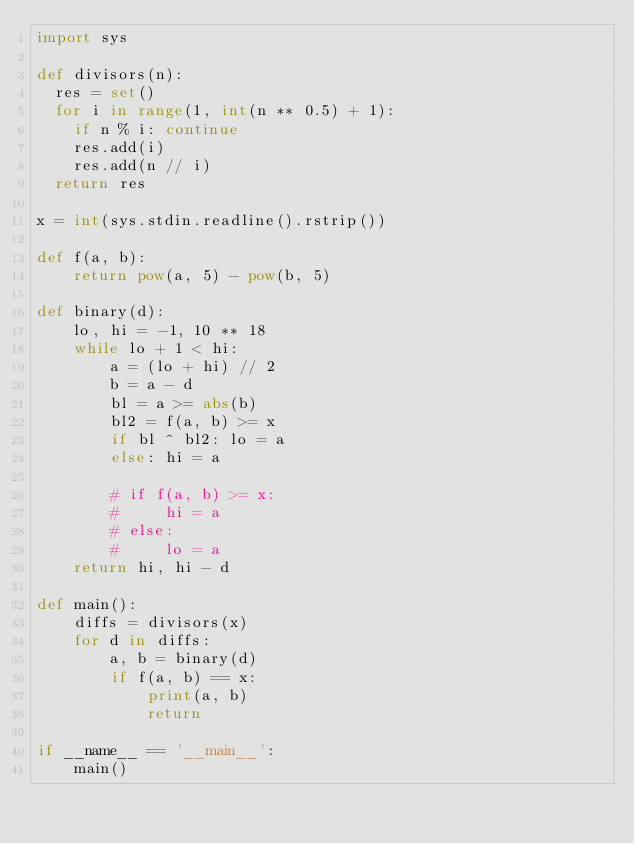Convert code to text. <code><loc_0><loc_0><loc_500><loc_500><_Python_>import sys

def divisors(n):
  res = set()
  for i in range(1, int(n ** 0.5) + 1):
    if n % i: continue
    res.add(i)
    res.add(n // i)
  return res

x = int(sys.stdin.readline().rstrip())

def f(a, b):
    return pow(a, 5) - pow(b, 5)

def binary(d):
    lo, hi = -1, 10 ** 18
    while lo + 1 < hi:
        a = (lo + hi) // 2 
        b = a - d 
        bl = a >= abs(b)
        bl2 = f(a, b) >= x
        if bl ^ bl2: lo = a
        else: hi = a

        # if f(a, b) >= x:
        #     hi = a 
        # else:
        #     lo = a
    return hi, hi - d

def main():
    diffs = divisors(x)
    for d in diffs:
        a, b = binary(d)
        if f(a, b) == x:
            print(a, b)
            return 

if __name__ == '__main__':
    main()</code> 